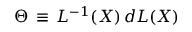Convert formula to latex. <formula><loc_0><loc_0><loc_500><loc_500>\Theta \, \equiv \, L ^ { - 1 } ( X ) \, d L ( X )</formula> 